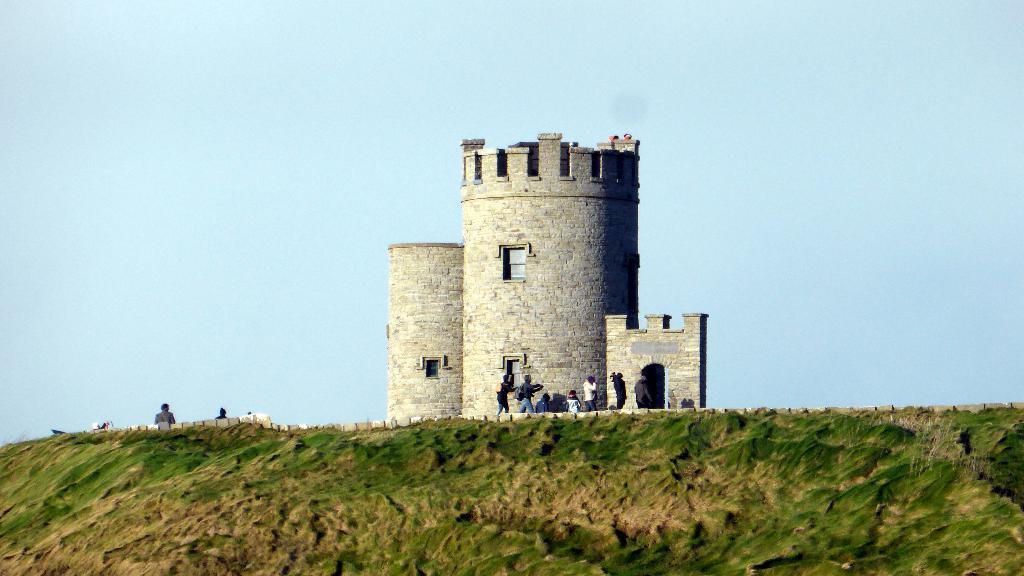What type of structure is present in the image? There is a building in the image. What type of vegetation can be seen in the image? There is grass in the image. What part of the natural environment is visible in the image? The sky is visible in the image. Are there any living beings present in the image? Yes, there are people in the image. Where can the advertisement for the pet store be found in the image? There is no advertisement for a pet store present in the image. Can you see any cobwebs in the image? There are no cobwebs visible in the image. 